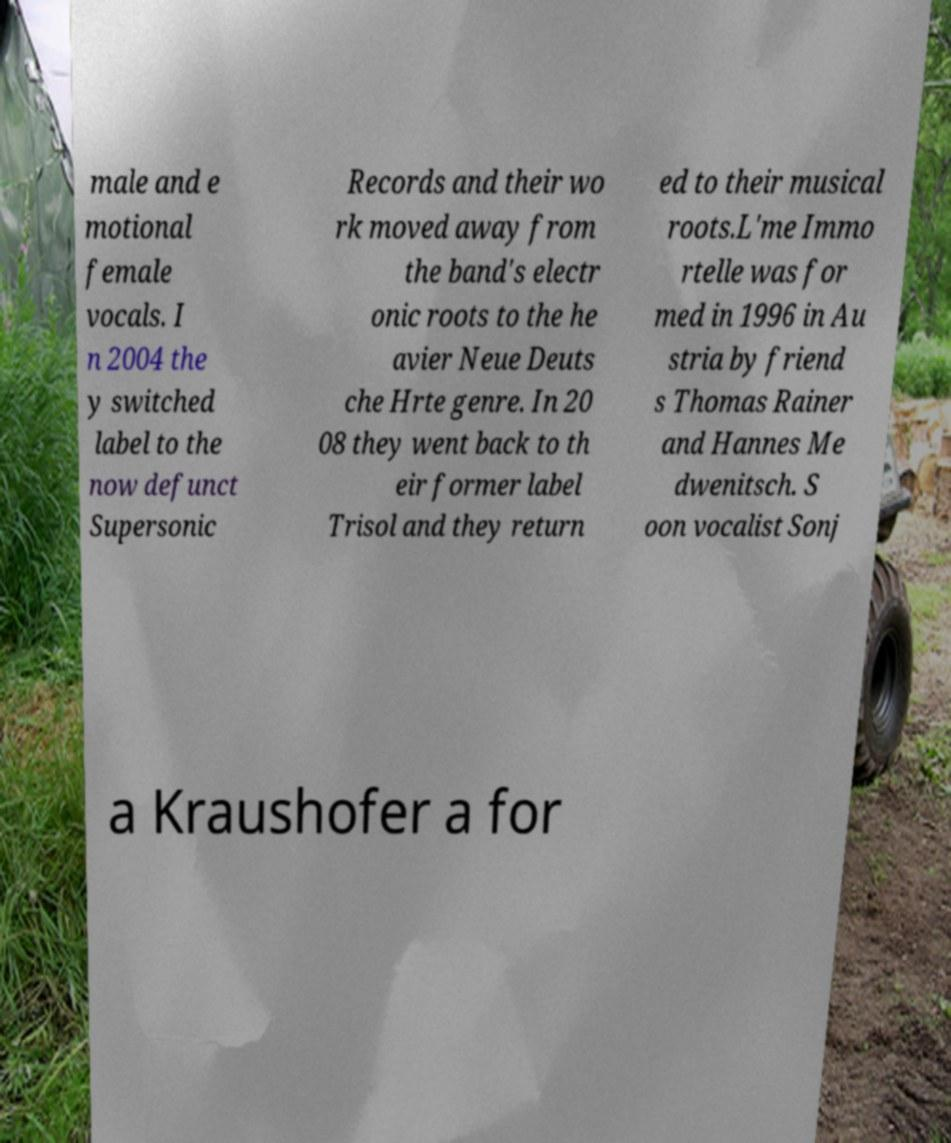Could you assist in decoding the text presented in this image and type it out clearly? male and e motional female vocals. I n 2004 the y switched label to the now defunct Supersonic Records and their wo rk moved away from the band's electr onic roots to the he avier Neue Deuts che Hrte genre. In 20 08 they went back to th eir former label Trisol and they return ed to their musical roots.L'me Immo rtelle was for med in 1996 in Au stria by friend s Thomas Rainer and Hannes Me dwenitsch. S oon vocalist Sonj a Kraushofer a for 